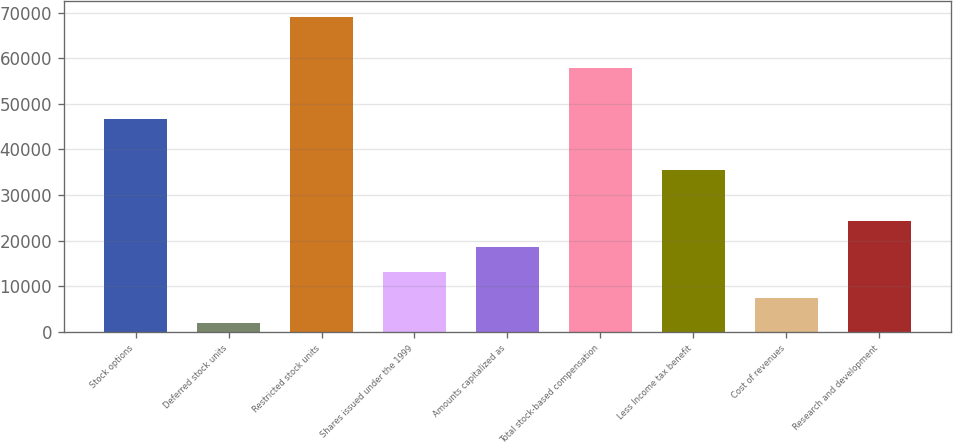Convert chart. <chart><loc_0><loc_0><loc_500><loc_500><bar_chart><fcel>Stock options<fcel>Deferred stock units<fcel>Restricted stock units<fcel>Shares issued under the 1999<fcel>Amounts capitalized as<fcel>Total stock-based compensation<fcel>Less Income tax benefit<fcel>Cost of revenues<fcel>Research and development<nl><fcel>46696.2<fcel>1885<fcel>69101.8<fcel>13087.8<fcel>18689.2<fcel>57899<fcel>35493.4<fcel>7486.4<fcel>24290.6<nl></chart> 